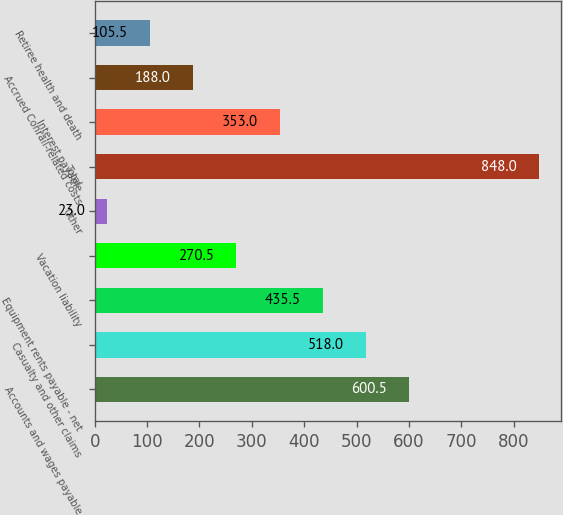Convert chart to OTSL. <chart><loc_0><loc_0><loc_500><loc_500><bar_chart><fcel>Accounts and wages payable<fcel>Casualty and other claims<fcel>Equipment rents payable - net<fcel>Vacation liability<fcel>Other<fcel>Total<fcel>Interest payable<fcel>Accrued Conrail-related costs<fcel>Retiree health and death<nl><fcel>600.5<fcel>518<fcel>435.5<fcel>270.5<fcel>23<fcel>848<fcel>353<fcel>188<fcel>105.5<nl></chart> 